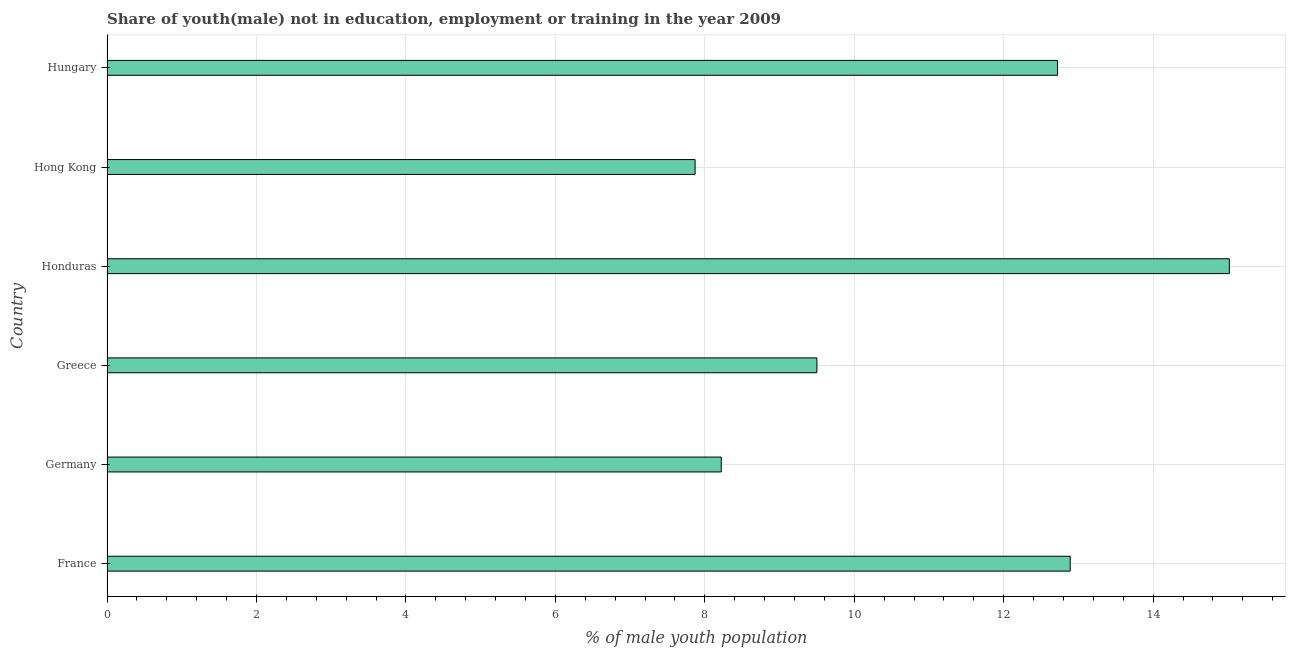Does the graph contain any zero values?
Your response must be concise. No. Does the graph contain grids?
Your answer should be compact. Yes. What is the title of the graph?
Give a very brief answer. Share of youth(male) not in education, employment or training in the year 2009. What is the label or title of the X-axis?
Provide a succinct answer. % of male youth population. What is the unemployed male youth population in Hungary?
Keep it short and to the point. 12.72. Across all countries, what is the maximum unemployed male youth population?
Your response must be concise. 15.02. Across all countries, what is the minimum unemployed male youth population?
Keep it short and to the point. 7.87. In which country was the unemployed male youth population maximum?
Ensure brevity in your answer.  Honduras. In which country was the unemployed male youth population minimum?
Provide a succinct answer. Hong Kong. What is the sum of the unemployed male youth population?
Keep it short and to the point. 66.22. What is the difference between the unemployed male youth population in Greece and Honduras?
Your response must be concise. -5.52. What is the average unemployed male youth population per country?
Provide a short and direct response. 11.04. What is the median unemployed male youth population?
Your answer should be compact. 11.11. What is the ratio of the unemployed male youth population in Greece to that in Honduras?
Your answer should be very brief. 0.63. Is the unemployed male youth population in Greece less than that in Hong Kong?
Offer a very short reply. No. What is the difference between the highest and the second highest unemployed male youth population?
Your answer should be compact. 2.13. What is the difference between the highest and the lowest unemployed male youth population?
Make the answer very short. 7.15. In how many countries, is the unemployed male youth population greater than the average unemployed male youth population taken over all countries?
Ensure brevity in your answer.  3. How many bars are there?
Make the answer very short. 6. Are all the bars in the graph horizontal?
Your response must be concise. Yes. How many countries are there in the graph?
Ensure brevity in your answer.  6. Are the values on the major ticks of X-axis written in scientific E-notation?
Offer a very short reply. No. What is the % of male youth population in France?
Give a very brief answer. 12.89. What is the % of male youth population in Germany?
Give a very brief answer. 8.22. What is the % of male youth population in Honduras?
Your response must be concise. 15.02. What is the % of male youth population of Hong Kong?
Offer a very short reply. 7.87. What is the % of male youth population in Hungary?
Keep it short and to the point. 12.72. What is the difference between the % of male youth population in France and Germany?
Your answer should be very brief. 4.67. What is the difference between the % of male youth population in France and Greece?
Make the answer very short. 3.39. What is the difference between the % of male youth population in France and Honduras?
Keep it short and to the point. -2.13. What is the difference between the % of male youth population in France and Hong Kong?
Give a very brief answer. 5.02. What is the difference between the % of male youth population in France and Hungary?
Provide a short and direct response. 0.17. What is the difference between the % of male youth population in Germany and Greece?
Make the answer very short. -1.28. What is the difference between the % of male youth population in Germany and Hong Kong?
Ensure brevity in your answer.  0.35. What is the difference between the % of male youth population in Greece and Honduras?
Provide a succinct answer. -5.52. What is the difference between the % of male youth population in Greece and Hong Kong?
Provide a short and direct response. 1.63. What is the difference between the % of male youth population in Greece and Hungary?
Ensure brevity in your answer.  -3.22. What is the difference between the % of male youth population in Honduras and Hong Kong?
Provide a short and direct response. 7.15. What is the difference between the % of male youth population in Hong Kong and Hungary?
Make the answer very short. -4.85. What is the ratio of the % of male youth population in France to that in Germany?
Provide a short and direct response. 1.57. What is the ratio of the % of male youth population in France to that in Greece?
Ensure brevity in your answer.  1.36. What is the ratio of the % of male youth population in France to that in Honduras?
Offer a terse response. 0.86. What is the ratio of the % of male youth population in France to that in Hong Kong?
Provide a succinct answer. 1.64. What is the ratio of the % of male youth population in France to that in Hungary?
Give a very brief answer. 1.01. What is the ratio of the % of male youth population in Germany to that in Greece?
Keep it short and to the point. 0.86. What is the ratio of the % of male youth population in Germany to that in Honduras?
Make the answer very short. 0.55. What is the ratio of the % of male youth population in Germany to that in Hong Kong?
Your response must be concise. 1.04. What is the ratio of the % of male youth population in Germany to that in Hungary?
Your answer should be compact. 0.65. What is the ratio of the % of male youth population in Greece to that in Honduras?
Offer a terse response. 0.63. What is the ratio of the % of male youth population in Greece to that in Hong Kong?
Make the answer very short. 1.21. What is the ratio of the % of male youth population in Greece to that in Hungary?
Provide a succinct answer. 0.75. What is the ratio of the % of male youth population in Honduras to that in Hong Kong?
Give a very brief answer. 1.91. What is the ratio of the % of male youth population in Honduras to that in Hungary?
Your response must be concise. 1.18. What is the ratio of the % of male youth population in Hong Kong to that in Hungary?
Ensure brevity in your answer.  0.62. 